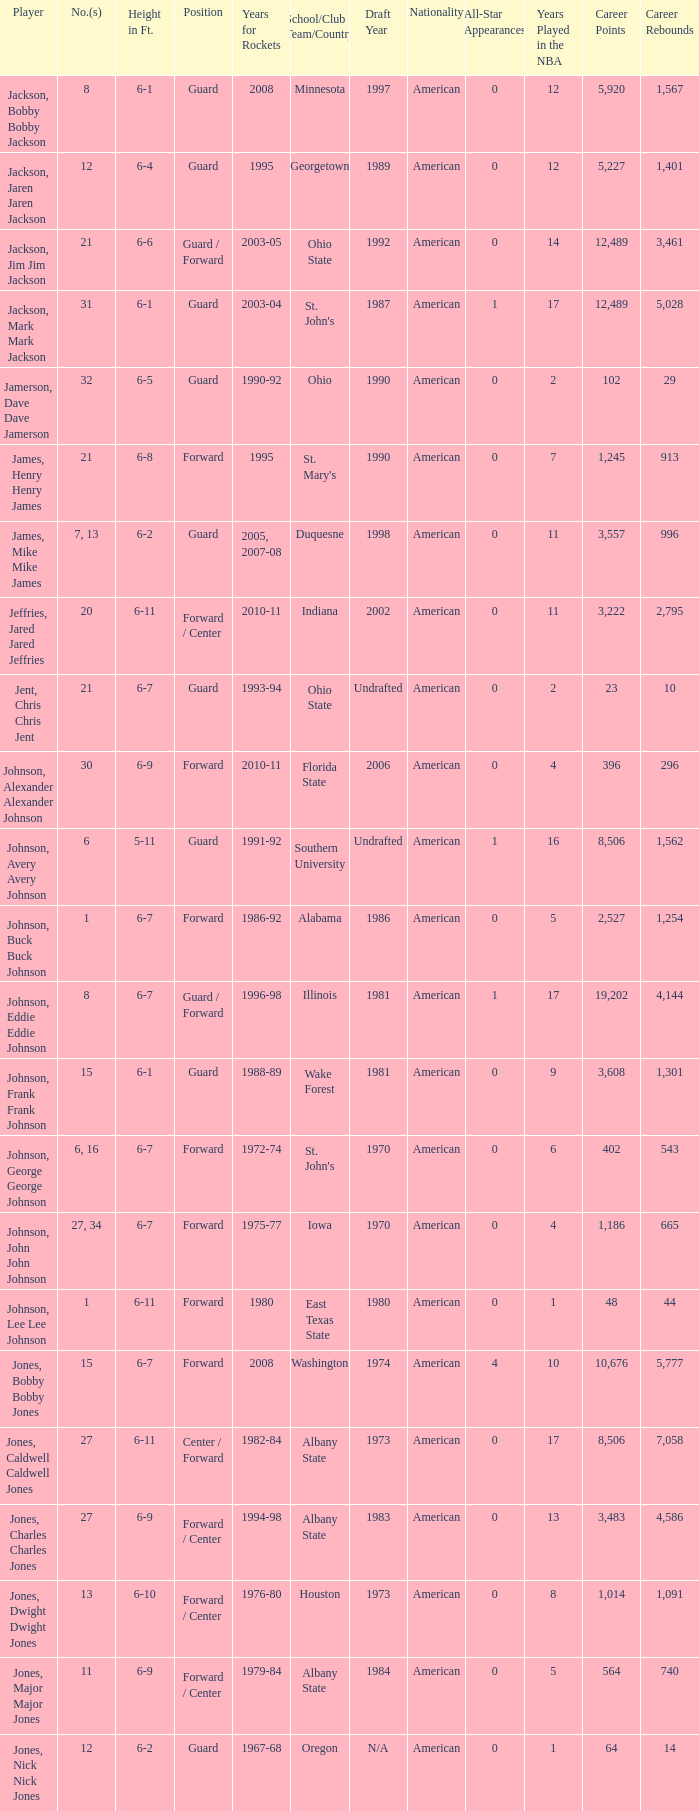Can you give me this table as a dict? {'header': ['Player', 'No.(s)', 'Height in Ft.', 'Position', 'Years for Rockets', 'School/Club Team/Country', 'Draft Year', 'Nationality', 'All-Star Appearances', 'Years Played in the NBA', 'Career Points', 'Career Rebounds'], 'rows': [['Jackson, Bobby Bobby Jackson', '8', '6-1', 'Guard', '2008', 'Minnesota', '1997', 'American', '0', '12', '5,920', '1,567'], ['Jackson, Jaren Jaren Jackson', '12', '6-4', 'Guard', '1995', 'Georgetown', '1989', 'American', '0', '12', '5,227', '1,401'], ['Jackson, Jim Jim Jackson', '21', '6-6', 'Guard / Forward', '2003-05', 'Ohio State', '1992', 'American', '0', '14', '12,489', '3,461'], ['Jackson, Mark Mark Jackson', '31', '6-1', 'Guard', '2003-04', "St. John's", '1987', 'American', '1', '17', '12,489', '5,028'], ['Jamerson, Dave Dave Jamerson', '32', '6-5', 'Guard', '1990-92', 'Ohio', '1990', 'American', '0', '2', '102', '29'], ['James, Henry Henry James', '21', '6-8', 'Forward', '1995', "St. Mary's", '1990', 'American', '0', '7', '1,245', '913'], ['James, Mike Mike James', '7, 13', '6-2', 'Guard', '2005, 2007-08', 'Duquesne', '1998', 'American', '0', '11', '3,557', '996'], ['Jeffries, Jared Jared Jeffries', '20', '6-11', 'Forward / Center', '2010-11', 'Indiana', '2002', 'American', '0', '11', '3,222', '2,795'], ['Jent, Chris Chris Jent', '21', '6-7', 'Guard', '1993-94', 'Ohio State', 'Undrafted', 'American', '0', '2', '23', '10'], ['Johnson, Alexander Alexander Johnson', '30', '6-9', 'Forward', '2010-11', 'Florida State', '2006', 'American', '0', '4', '396', '296'], ['Johnson, Avery Avery Johnson', '6', '5-11', 'Guard', '1991-92', 'Southern University', 'Undrafted', 'American', '1', '16', '8,506', '1,562'], ['Johnson, Buck Buck Johnson', '1', '6-7', 'Forward', '1986-92', 'Alabama', '1986', 'American', '0', '5', '2,527', '1,254'], ['Johnson, Eddie Eddie Johnson', '8', '6-7', 'Guard / Forward', '1996-98', 'Illinois', '1981', 'American', '1', '17', '19,202', '4,144'], ['Johnson, Frank Frank Johnson', '15', '6-1', 'Guard', '1988-89', 'Wake Forest', '1981', 'American', '0', '9', '3,608', '1,301'], ['Johnson, George George Johnson', '6, 16', '6-7', 'Forward', '1972-74', "St. John's", '1970', 'American', '0', '6', '402', '543'], ['Johnson, John John Johnson', '27, 34', '6-7', 'Forward', '1975-77', 'Iowa', '1970', 'American', '0', '4', '1,186', '665'], ['Johnson, Lee Lee Johnson', '1', '6-11', 'Forward', '1980', 'East Texas State', '1980', 'American', '0', '1', '48', '44'], ['Jones, Bobby Bobby Jones', '15', '6-7', 'Forward', '2008', 'Washington', '1974', 'American', '4', '10', '10,676', '5,777'], ['Jones, Caldwell Caldwell Jones', '27', '6-11', 'Center / Forward', '1982-84', 'Albany State', '1973', 'American', '0', '17', '8,506', '7,058'], ['Jones, Charles Charles Jones', '27', '6-9', 'Forward / Center', '1994-98', 'Albany State', '1983', 'American', '0', '13', '3,483', '4,586'], ['Jones, Dwight Dwight Jones', '13', '6-10', 'Forward / Center', '1976-80', 'Houston', '1973', 'American', '0', '8', '1,014', '1,091'], ['Jones, Major Major Jones', '11', '6-9', 'Forward / Center', '1979-84', 'Albany State', '1984', 'American', '0', '5', '564', '740'], ['Jones, Nick Nick Jones', '12', '6-2', 'Guard', '1967-68', 'Oregon', 'N/A', 'American', '0', '1', '64', '14']]} Which player who played for the Rockets for the years 1986-92? Johnson, Buck Buck Johnson. 